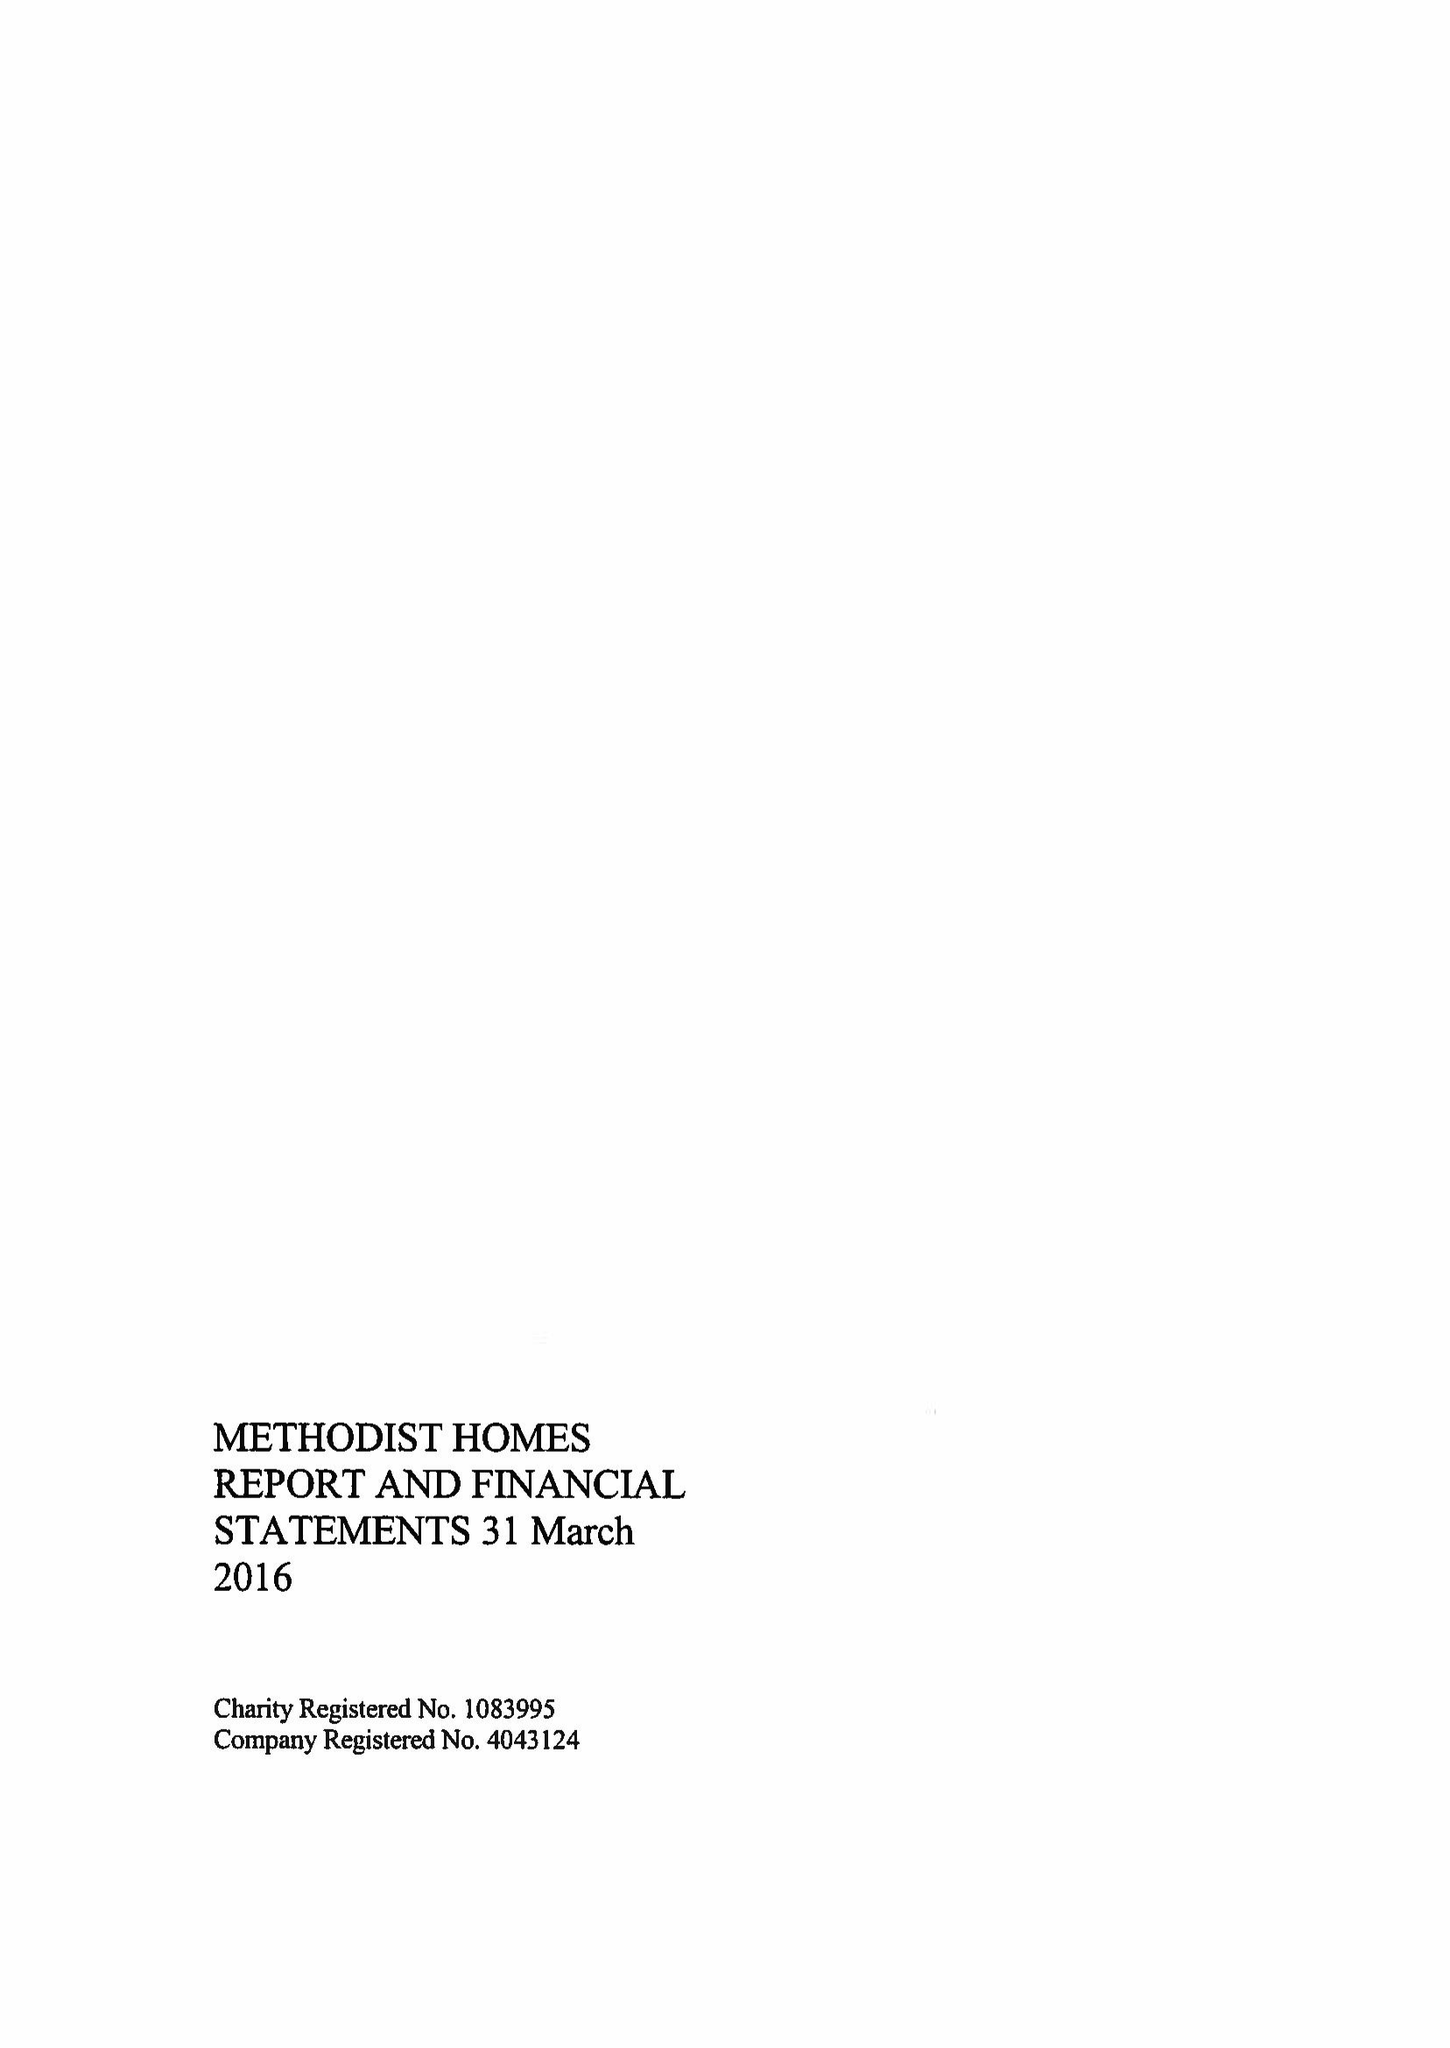What is the value for the charity_name?
Answer the question using a single word or phrase. Methodist Homes 